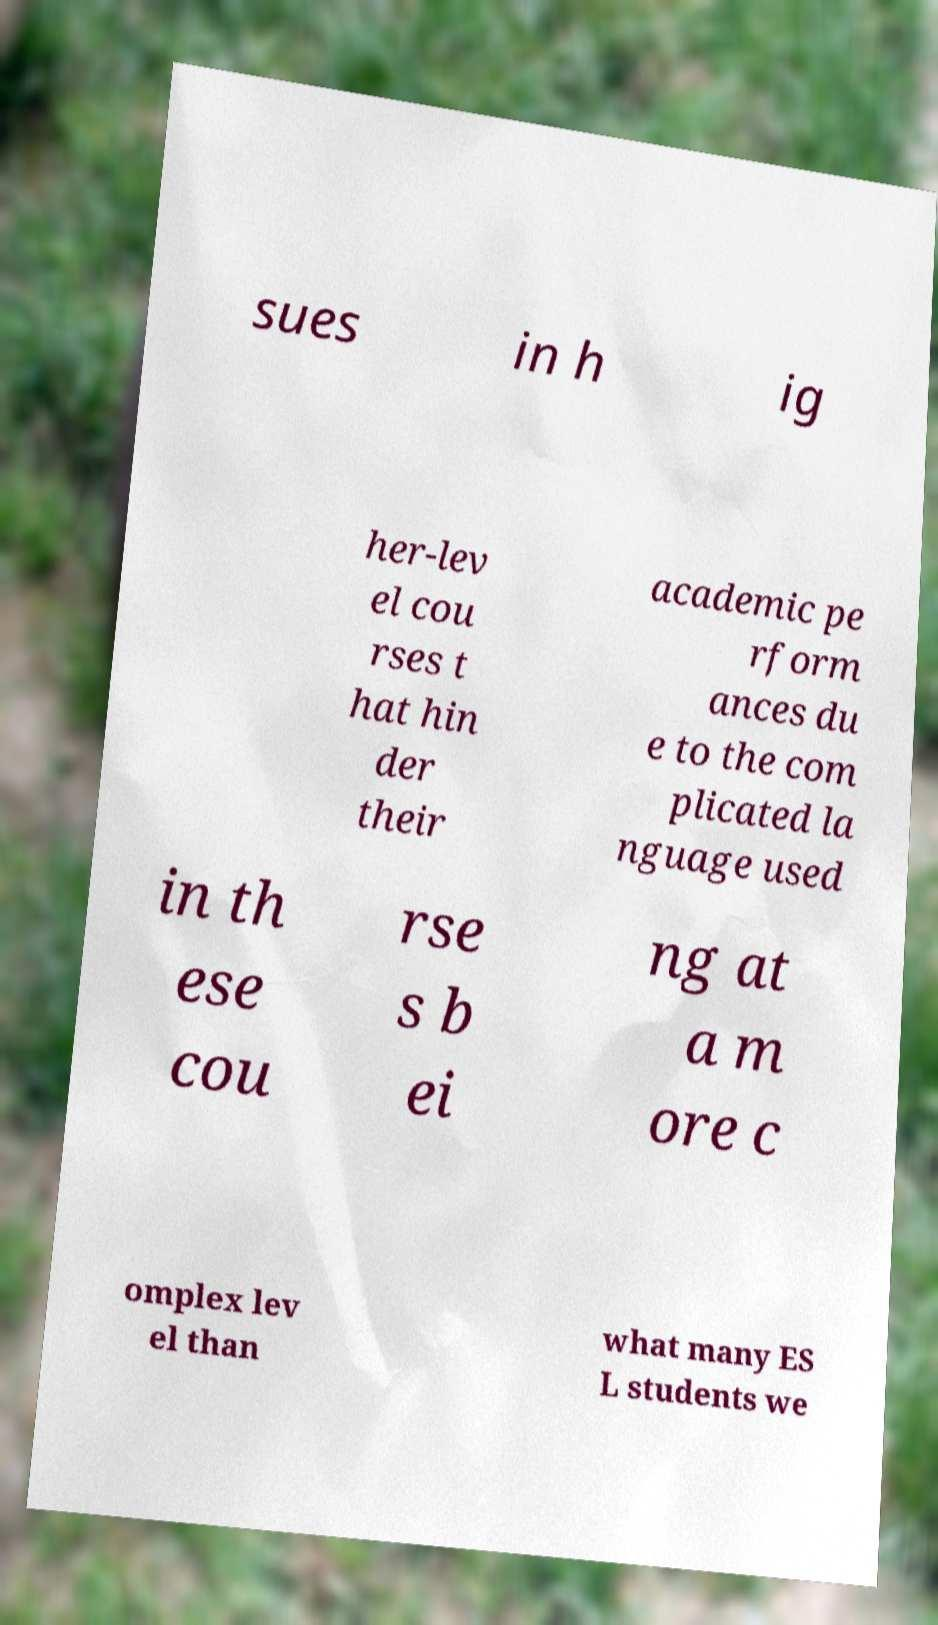Can you read and provide the text displayed in the image?This photo seems to have some interesting text. Can you extract and type it out for me? sues in h ig her-lev el cou rses t hat hin der their academic pe rform ances du e to the com plicated la nguage used in th ese cou rse s b ei ng at a m ore c omplex lev el than what many ES L students we 